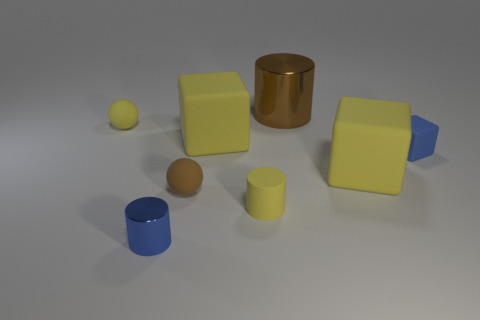How many cylinders are both in front of the tiny brown rubber object and behind the tiny shiny cylinder?
Your response must be concise. 1. The metallic thing that is behind the big matte cube on the left side of the brown cylinder is what color?
Ensure brevity in your answer.  Brown. Are there the same number of brown objects that are in front of the matte cylinder and big purple cylinders?
Offer a very short reply. Yes. There is a small rubber object that is to the right of the brown thing that is on the right side of the brown rubber object; how many tiny yellow matte cylinders are behind it?
Make the answer very short. 0. What color is the tiny object to the right of the brown cylinder?
Provide a short and direct response. Blue. The thing that is both behind the tiny rubber block and to the right of the small yellow cylinder is made of what material?
Your answer should be very brief. Metal. There is a metal thing on the right side of the tiny brown thing; what number of yellow balls are on the left side of it?
Your response must be concise. 1. There is a blue metallic thing; what shape is it?
Provide a succinct answer. Cylinder. The blue thing that is made of the same material as the big brown object is what shape?
Keep it short and to the point. Cylinder. Do the brown shiny thing that is to the right of the brown rubber ball and the tiny blue shiny object have the same shape?
Offer a terse response. Yes. 